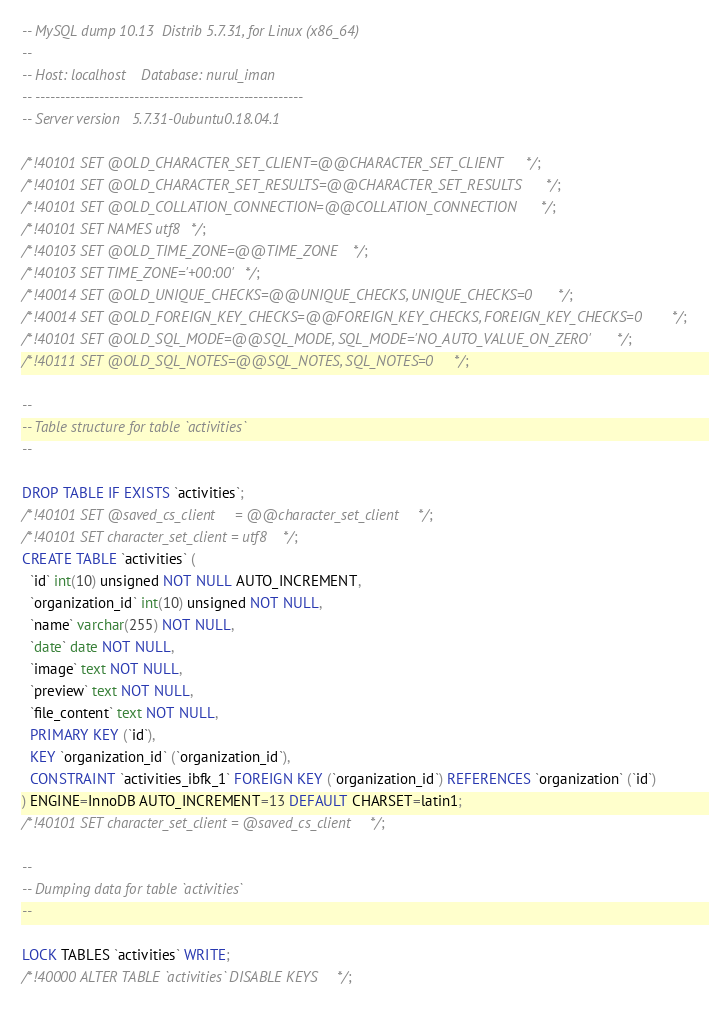<code> <loc_0><loc_0><loc_500><loc_500><_SQL_>-- MySQL dump 10.13  Distrib 5.7.31, for Linux (x86_64)
--
-- Host: localhost    Database: nurul_iman
-- ------------------------------------------------------
-- Server version	5.7.31-0ubuntu0.18.04.1

/*!40101 SET @OLD_CHARACTER_SET_CLIENT=@@CHARACTER_SET_CLIENT */;
/*!40101 SET @OLD_CHARACTER_SET_RESULTS=@@CHARACTER_SET_RESULTS */;
/*!40101 SET @OLD_COLLATION_CONNECTION=@@COLLATION_CONNECTION */;
/*!40101 SET NAMES utf8 */;
/*!40103 SET @OLD_TIME_ZONE=@@TIME_ZONE */;
/*!40103 SET TIME_ZONE='+00:00' */;
/*!40014 SET @OLD_UNIQUE_CHECKS=@@UNIQUE_CHECKS, UNIQUE_CHECKS=0 */;
/*!40014 SET @OLD_FOREIGN_KEY_CHECKS=@@FOREIGN_KEY_CHECKS, FOREIGN_KEY_CHECKS=0 */;
/*!40101 SET @OLD_SQL_MODE=@@SQL_MODE, SQL_MODE='NO_AUTO_VALUE_ON_ZERO' */;
/*!40111 SET @OLD_SQL_NOTES=@@SQL_NOTES, SQL_NOTES=0 */;

--
-- Table structure for table `activities`
--

DROP TABLE IF EXISTS `activities`;
/*!40101 SET @saved_cs_client     = @@character_set_client */;
/*!40101 SET character_set_client = utf8 */;
CREATE TABLE `activities` (
  `id` int(10) unsigned NOT NULL AUTO_INCREMENT,
  `organization_id` int(10) unsigned NOT NULL,
  `name` varchar(255) NOT NULL,
  `date` date NOT NULL,
  `image` text NOT NULL,
  `preview` text NOT NULL,
  `file_content` text NOT NULL,
  PRIMARY KEY (`id`),
  KEY `organization_id` (`organization_id`),
  CONSTRAINT `activities_ibfk_1` FOREIGN KEY (`organization_id`) REFERENCES `organization` (`id`)
) ENGINE=InnoDB AUTO_INCREMENT=13 DEFAULT CHARSET=latin1;
/*!40101 SET character_set_client = @saved_cs_client */;

--
-- Dumping data for table `activities`
--

LOCK TABLES `activities` WRITE;
/*!40000 ALTER TABLE `activities` DISABLE KEYS */;</code> 